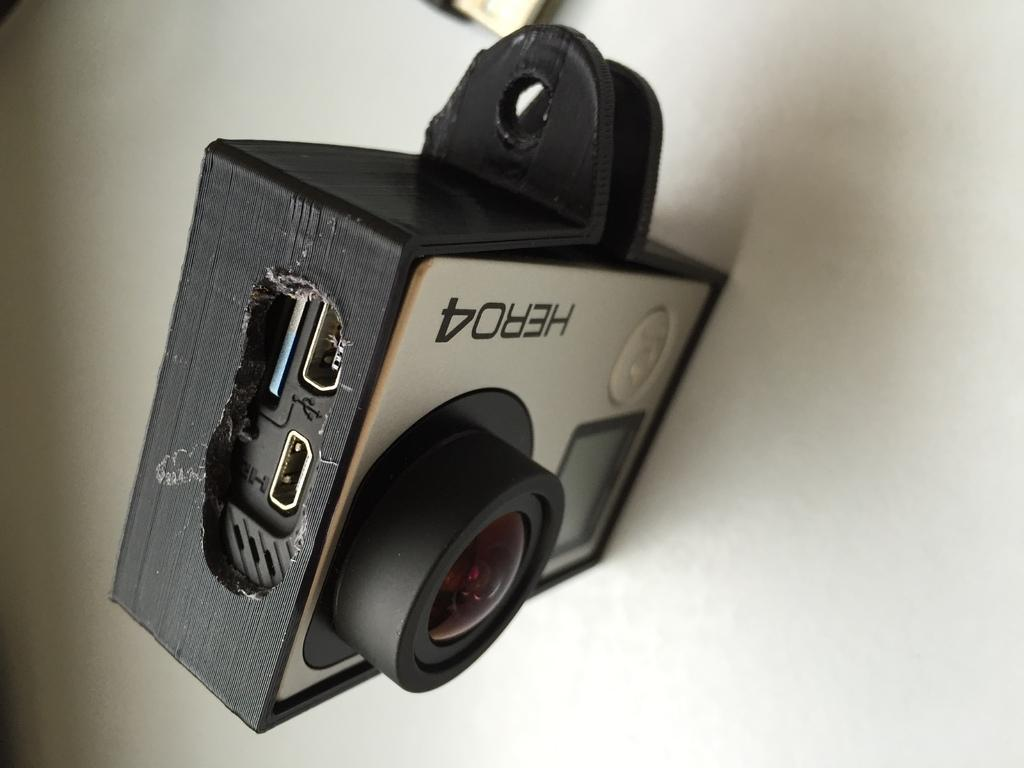What object is the main focus of the image? There is a camera in the image. Can you describe any additional details about the camera? There is writing on the camera. What is the color of the surface the camera is placed on? The camera is on a white surface. Can you hear the whistle of the fireman in the image? There is no fireman or whistle present in the image; it only features a camera with writing on it placed on a white surface. 